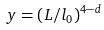<formula> <loc_0><loc_0><loc_500><loc_500>y = ( L / l _ { 0 } ) ^ { 4 - d }</formula> 